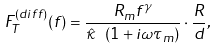Convert formula to latex. <formula><loc_0><loc_0><loc_500><loc_500>F _ { T } ^ { ( d i f f ) } ( f ) = \frac { R _ { m } f ^ { \gamma } } { \hat { \kappa } \ ( 1 + i \omega \tau _ { m } ) } \cdot \frac { R } { d } ,</formula> 